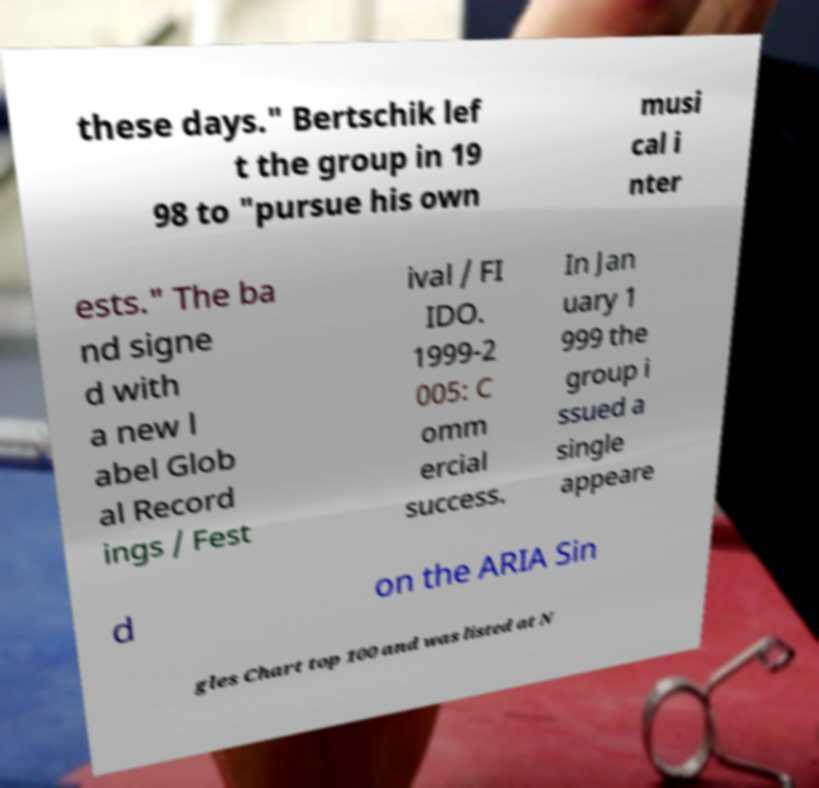There's text embedded in this image that I need extracted. Can you transcribe it verbatim? these days." Bertschik lef t the group in 19 98 to "pursue his own musi cal i nter ests." The ba nd signe d with a new l abel Glob al Record ings / Fest ival / FI IDO. 1999-2 005: C omm ercial success. In Jan uary 1 999 the group i ssued a single appeare d on the ARIA Sin gles Chart top 100 and was listed at N 